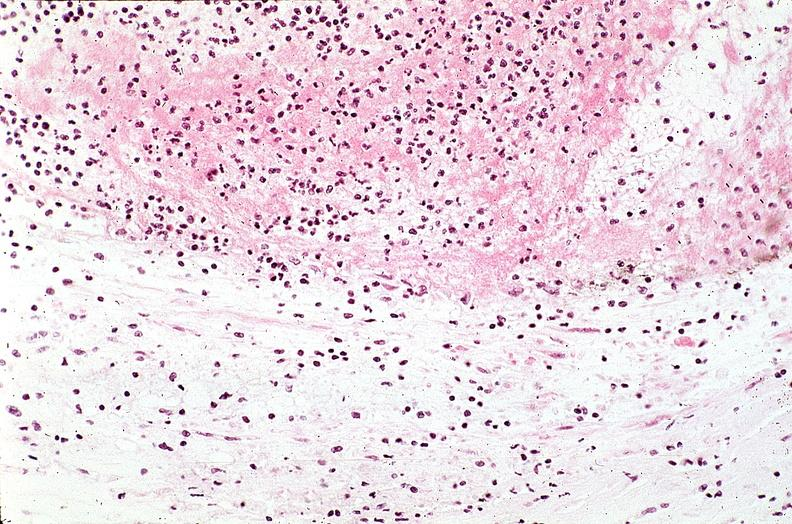does typical tuberculous exudate show coronary artery with atherosclerosis and thrombotic occlusion?
Answer the question using a single word or phrase. No 